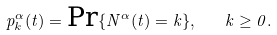<formula> <loc_0><loc_0><loc_500><loc_500>p _ { k } ^ { \alpha } ( t ) = \text {Pr} \{ N ^ { \alpha } ( t ) = k \} , \quad k \geq 0 .</formula> 